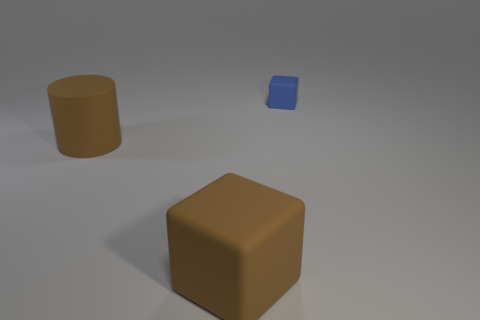Add 1 large brown rubber cylinders. How many objects exist? 4 Subtract 1 cylinders. How many cylinders are left? 0 Subtract all cubes. How many objects are left? 1 Subtract all gray cubes. How many blue cylinders are left? 0 Subtract all brown cubes. How many cubes are left? 1 Subtract 0 red cylinders. How many objects are left? 3 Subtract all brown blocks. Subtract all brown cylinders. How many blocks are left? 1 Subtract all blue balls. Subtract all blue matte blocks. How many objects are left? 2 Add 2 tiny blue blocks. How many tiny blue blocks are left? 3 Add 1 cyan cylinders. How many cyan cylinders exist? 1 